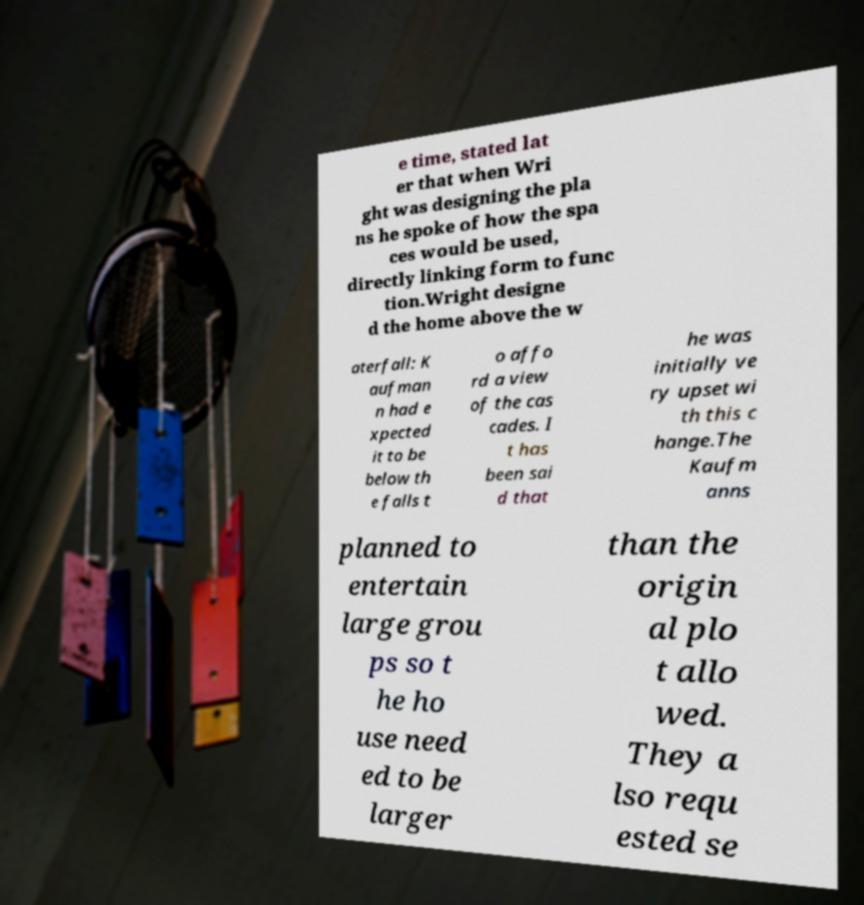There's text embedded in this image that I need extracted. Can you transcribe it verbatim? e time, stated lat er that when Wri ght was designing the pla ns he spoke of how the spa ces would be used, directly linking form to func tion.Wright designe d the home above the w aterfall: K aufman n had e xpected it to be below th e falls t o affo rd a view of the cas cades. I t has been sai d that he was initially ve ry upset wi th this c hange.The Kaufm anns planned to entertain large grou ps so t he ho use need ed to be larger than the origin al plo t allo wed. They a lso requ ested se 